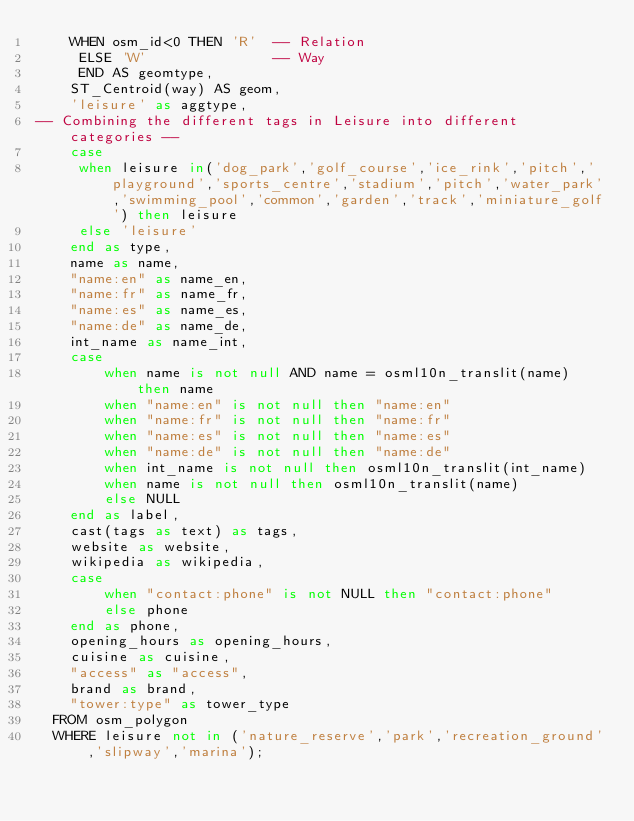Convert code to text. <code><loc_0><loc_0><loc_500><loc_500><_SQL_>    WHEN osm_id<0 THEN 'R'  -- Relation
     ELSE 'W'               -- Way
     END AS geomtype,
    ST_Centroid(way) AS geom,
    'leisure' as aggtype,
-- Combining the different tags in Leisure into different categories --
    case
     when leisure in('dog_park','golf_course','ice_rink','pitch','playground','sports_centre','stadium','pitch','water_park','swimming_pool','common','garden','track','miniature_golf') then leisure
     else 'leisure'
    end as type,
    name as name,
    "name:en" as name_en,
    "name:fr" as name_fr,
    "name:es" as name_es,
    "name:de" as name_de,
    int_name as name_int,
    case
        when name is not null AND name = osml10n_translit(name) then name
        when "name:en" is not null then "name:en"
        when "name:fr" is not null then "name:fr"
        when "name:es" is not null then "name:es"
        when "name:de" is not null then "name:de"
        when int_name is not null then osml10n_translit(int_name)
        when name is not null then osml10n_translit(name)
        else NULL
    end as label,
    cast(tags as text) as tags,
    website as website,
    wikipedia as wikipedia,
    case
        when "contact:phone" is not NULL then "contact:phone"
        else phone
    end as phone,
    opening_hours as opening_hours,
    cuisine as cuisine,
    "access" as "access",
    brand as brand,
    "tower:type" as tower_type
  FROM osm_polygon
  WHERE leisure not in ('nature_reserve','park','recreation_ground','slipway','marina');
</code> 